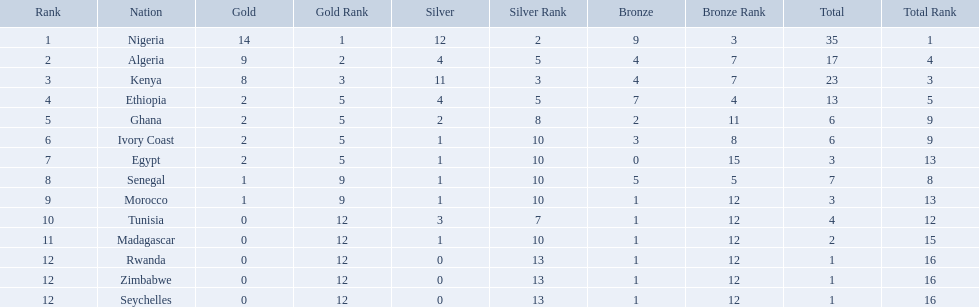What nations competed at the 1989 african championships in athletics? Nigeria, Algeria, Kenya, Ethiopia, Ghana, Ivory Coast, Egypt, Senegal, Morocco, Tunisia, Madagascar, Rwanda, Zimbabwe, Seychelles. What nations earned bronze medals? Nigeria, Algeria, Kenya, Ethiopia, Ghana, Ivory Coast, Senegal, Morocco, Tunisia, Madagascar, Rwanda, Zimbabwe, Seychelles. What nation did not earn a bronze medal? Egypt. 